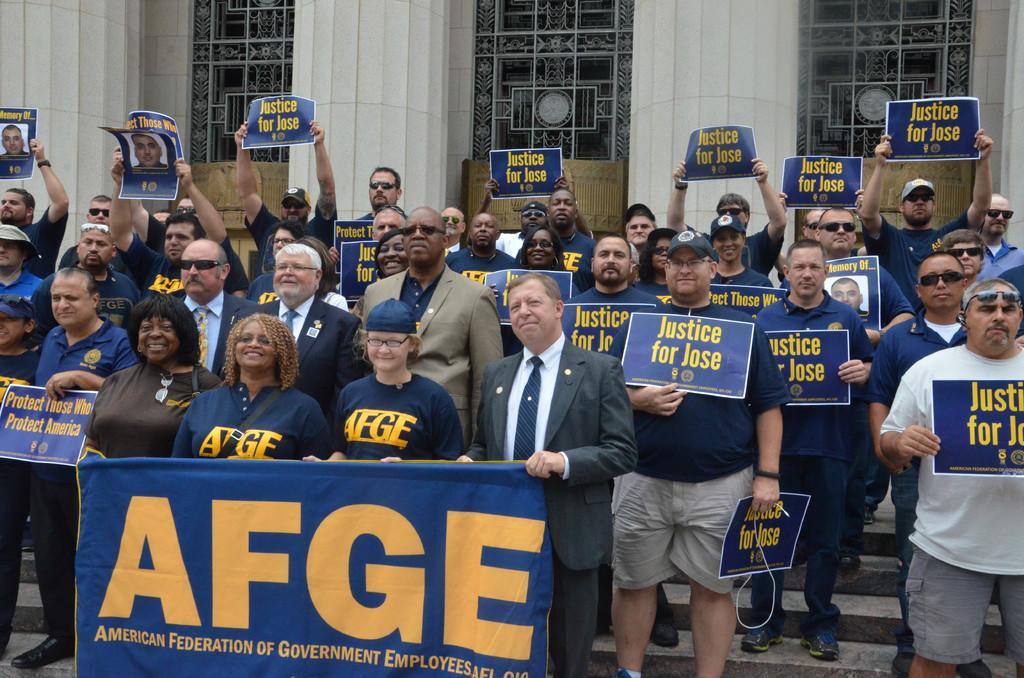Could you give a brief overview of what you see in this image? There are many people holding posters. In the front few are holding a banner. Some are wearing caps and goggles. In the back there is a building. Also there are steps. 